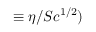Convert formula to latex. <formula><loc_0><loc_0><loc_500><loc_500>\equiv \eta / S c ^ { 1 / 2 } )</formula> 